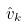<formula> <loc_0><loc_0><loc_500><loc_500>\hat { v } _ { k }</formula> 